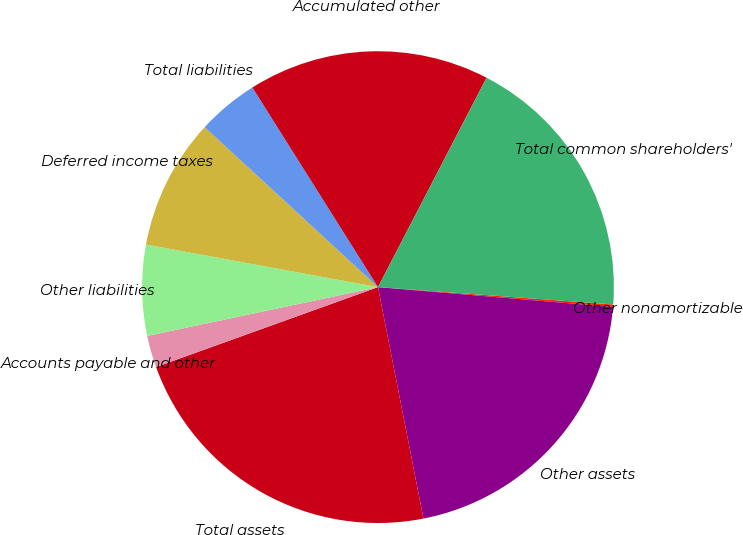Convert chart to OTSL. <chart><loc_0><loc_0><loc_500><loc_500><pie_chart><fcel>Other nonamortizable<fcel>Other assets<fcel>Total assets<fcel>Accounts payable and other<fcel>Other liabilities<fcel>Deferred income taxes<fcel>Total liabilities<fcel>Accumulated other<fcel>Total common shareholders'<nl><fcel>0.17%<fcel>20.57%<fcel>22.59%<fcel>2.18%<fcel>6.21%<fcel>8.97%<fcel>4.2%<fcel>16.55%<fcel>18.56%<nl></chart> 